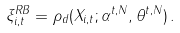<formula> <loc_0><loc_0><loc_500><loc_500>\xi ^ { R B } _ { i , t } = \rho _ { d } ( X _ { i , t } ; \alpha ^ { t , N } , \theta ^ { t , N } ) \, .</formula> 